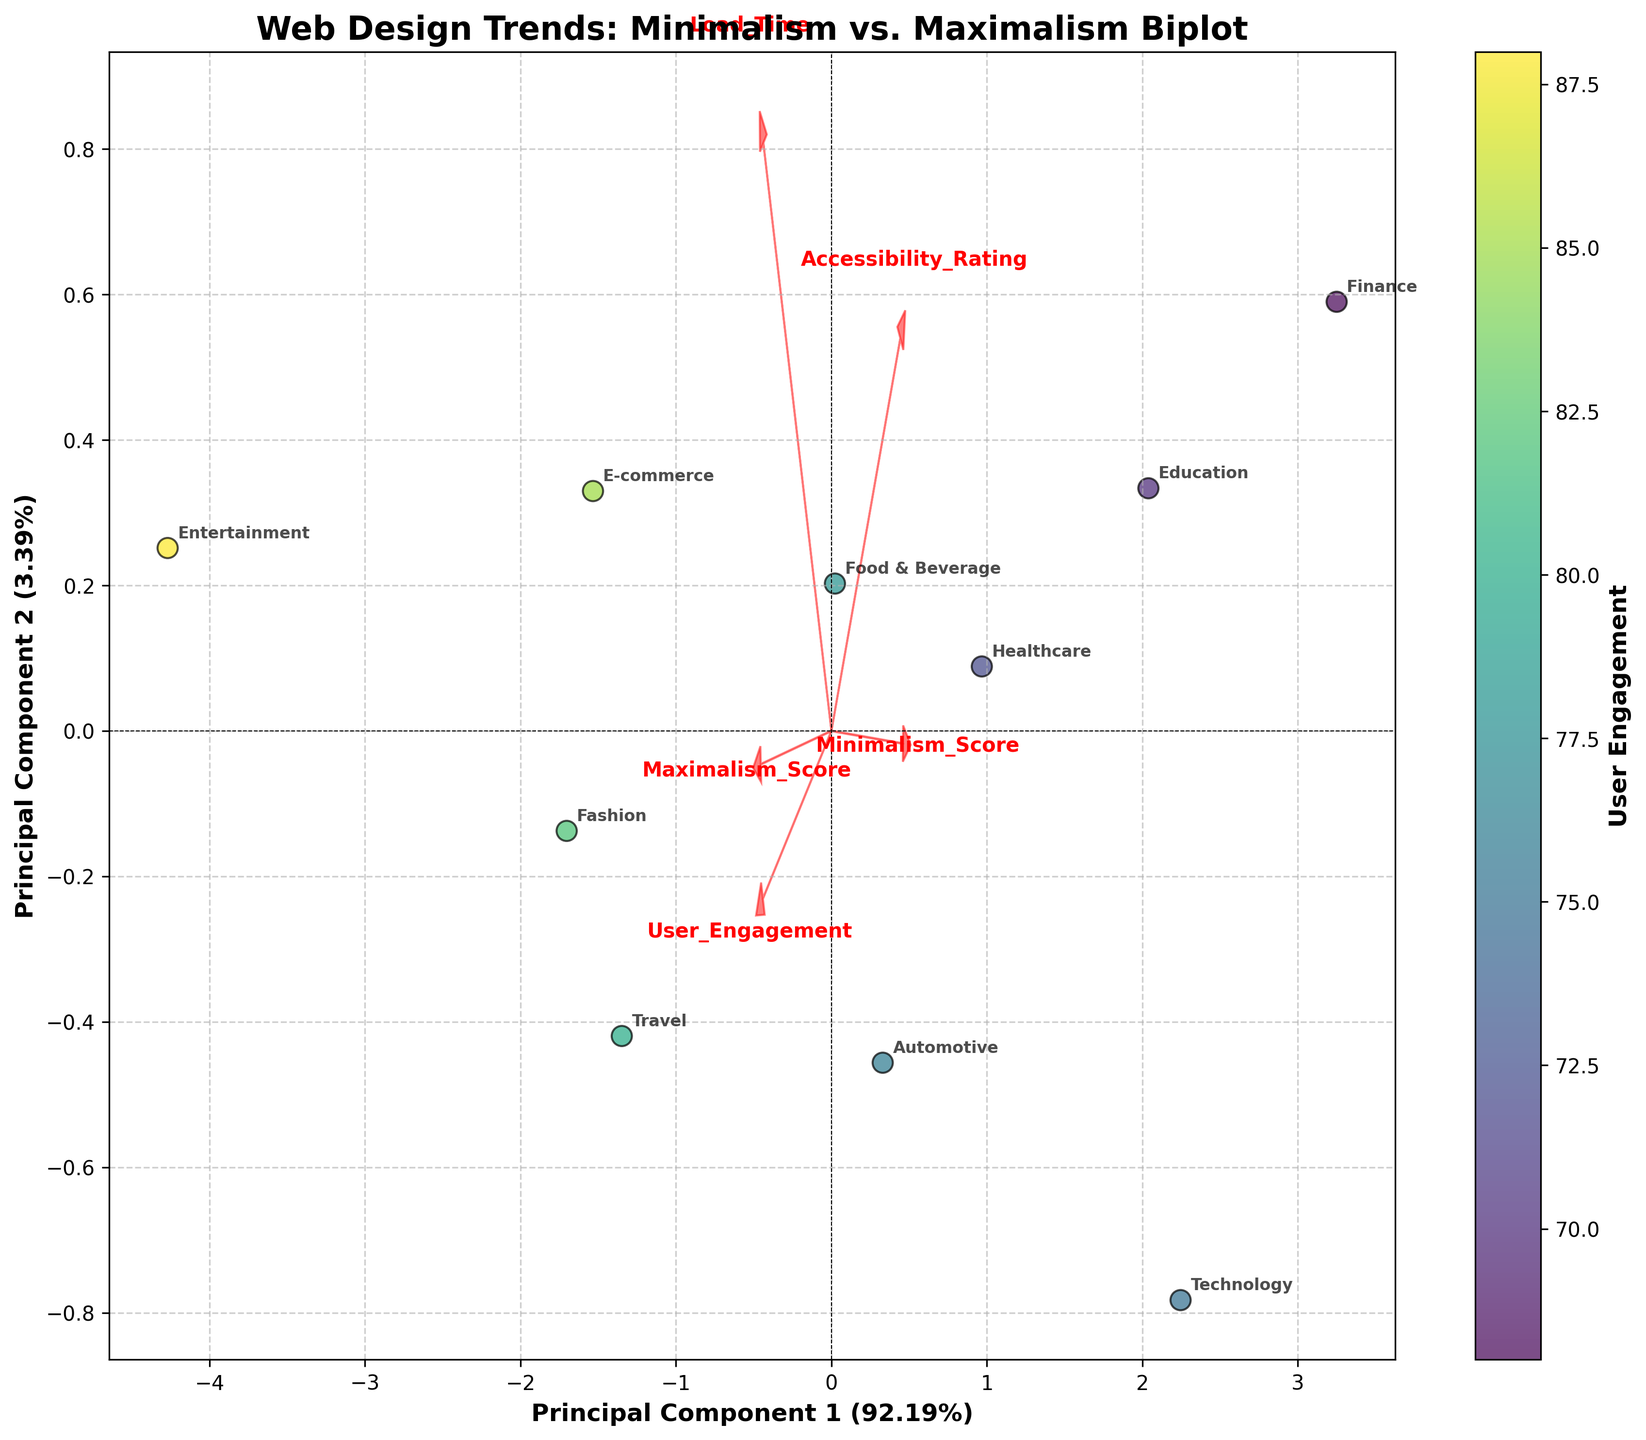What is the title of the plot? The title of the plot is located at the top of the graph. By reading this, we can identify it as "Web Design Trends: Minimalism vs. Maximalism Biplot".
Answer: Web Design Trends: Minimalism vs. Maximalism Biplot Which industry has the highest User Engagement? The color intensity on the scatter plot represents User Engagement, with darker colors indicating higher engagement. The darkest point corresponds to the Entertainment industry.
Answer: Entertainment Which feature vector has the longest arrow, and what might this signify? In the biplot, the length of the arrow represents the strength or importance of the feature. "Load Time" appears to have the longest arrow, indicating it has a significant influence on the first two principal components.
Answer: Load Time What are the axis labels and their percentages? The axis labels are located along the X and Y axes. The X-axis is labeled "Principal Component 1 (x%)" and the Y-axis is labeled "Principal Component 2 (y%)". The percentages indicate the explained variance by each principal component. For this plot, they are approximately 52% and 23%, respectively.
Answer: Principal Component 1 (52%), Principal Component 2 (23%) Which two industries are closest to each other on the biplot, suggesting similar web design trends? By examining the proximity of points on the biplot, we see that the Food & Beverage and Automotive industries are closest to each other, indicating they have similar web design trends in terms of the principal components.
Answer: Food & Beverage and Automotive How does the Travel industry's position relate to Minimalism and Maximalism scores? The Travel industry's point can be found by tracing its position relative to the feature vectors (arrows). The position indicates that it has moderate scores for both Minimalism and Maximalism, lying somewhat centrally but tending slightly towards Maximalism.
Answer: Moderate Minimalism, slightly higher Maximalism Which feature vector is oriented most horizontally, and what does it represent? Analyzing the directions of the arrows, "Load Time" is the most horizontally oriented vector. This signifies that Load Time contributes substantially to Principal Component 1.
Answer: Load Time What can you infer about the relationship between Minimalism scores and Accessibility ratings from the plot? The directions of the "Minimalism Score" and "Accessibility Rating" arrows are roughly aligned, implying a positive correlation between these two features. As Minimalism scores increase, Accessibility ratings tend to increase as well.
Answer: Positive correlation What is the primary separation between Technology and Fashion industries on the plot? By comparing the positions of Technology and Fashion, Technology lies high in Minimalism scores (left side of the plot) and low in Maximalism scores, while Fashion is the opposite with high Maximalism scores and lower Minimalism scores.
Answer: Minimalism vs. Maximalism What does the position of Healthcare suggest about its Load Time and User Engagement? The Healthcare industry is positioned where "Load Time" has low values (less to the right on the horizontal axis), and its User Engagement color is moderate, suggesting positive but not highly engaged users.
Answer: Low Load Time, moderate User Engagement 